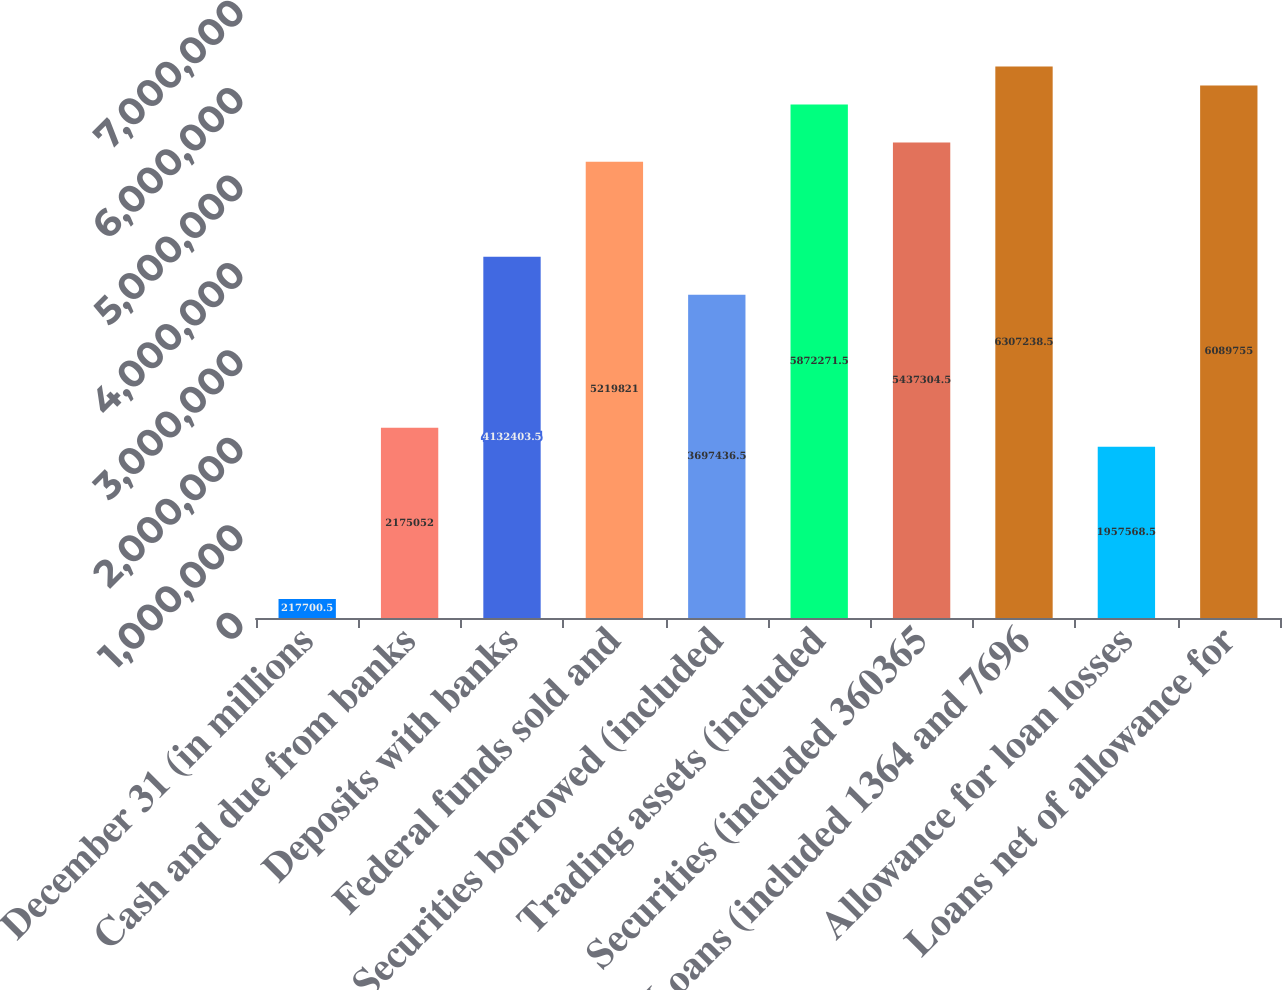Convert chart. <chart><loc_0><loc_0><loc_500><loc_500><bar_chart><fcel>December 31 (in millions<fcel>Cash and due from banks<fcel>Deposits with banks<fcel>Federal funds sold and<fcel>Securities borrowed (included<fcel>Trading assets (included<fcel>Securities (included 360365<fcel>Loans (included 1364 and 7696<fcel>Allowance for loan losses<fcel>Loans net of allowance for<nl><fcel>217700<fcel>2.17505e+06<fcel>4.1324e+06<fcel>5.21982e+06<fcel>3.69744e+06<fcel>5.87227e+06<fcel>5.4373e+06<fcel>6.30724e+06<fcel>1.95757e+06<fcel>6.08976e+06<nl></chart> 